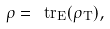Convert formula to latex. <formula><loc_0><loc_0><loc_500><loc_500>\rho = \ t r _ { E } ( \rho _ { T } ) ,</formula> 